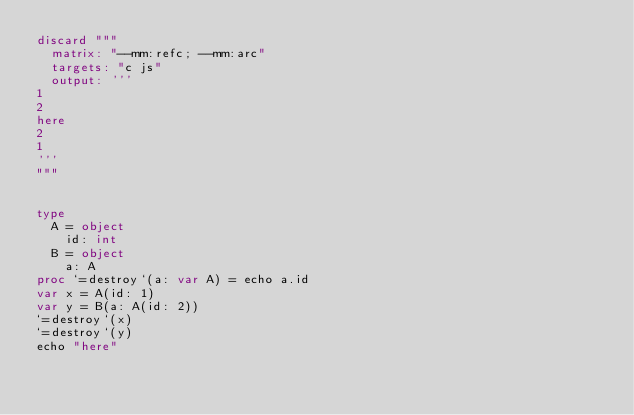Convert code to text. <code><loc_0><loc_0><loc_500><loc_500><_Nim_>discard """
  matrix: "--mm:refc; --mm:arc"
  targets: "c js"
  output: '''
1
2
here
2
1
'''
"""


type
  A = object
    id: int
  B = object
    a: A
proc `=destroy`(a: var A) = echo a.id
var x = A(id: 1)
var y = B(a: A(id: 2))
`=destroy`(x)
`=destroy`(y)
echo "here"</code> 